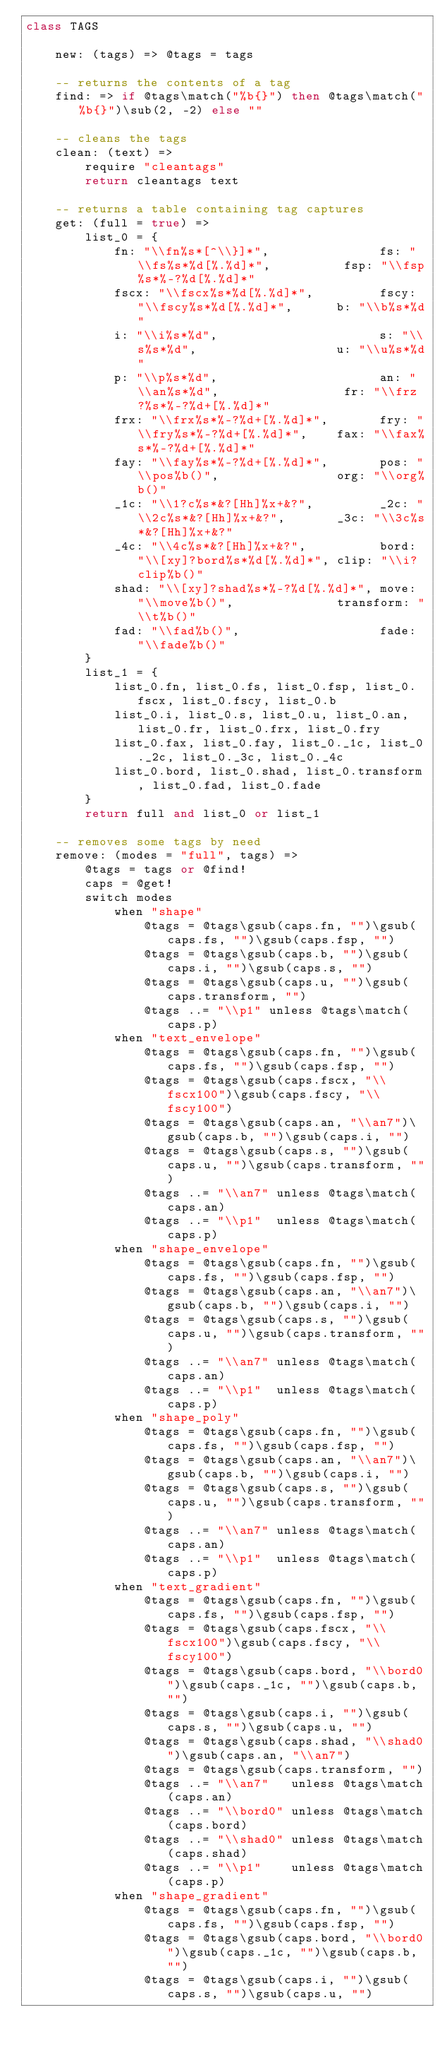<code> <loc_0><loc_0><loc_500><loc_500><_MoonScript_>class TAGS

    new: (tags) => @tags = tags

    -- returns the contents of a tag
    find: => if @tags\match("%b{}") then @tags\match("%b{}")\sub(2, -2) else ""

    -- cleans the tags
    clean: (text) =>
        require "cleantags"
        return cleantags text

    -- returns a table containing tag captures
    get: (full = true) =>
        list_0 = {
            fn: "\\fn%s*[^\\}]*",               fs: "\\fs%s*%d[%.%d]*",          fsp: "\\fsp%s*%-?%d[%.%d]*"
            fscx: "\\fscx%s*%d[%.%d]*",         fscy: "\\fscy%s*%d[%.%d]*",      b: "\\b%s*%d"
            i: "\\i%s*%d",                      s: "\\s%s*%d",                   u: "\\u%s*%d"
            p: "\\p%s*%d",                      an: "\\an%s*%d",                 fr: "\\frz?%s*%-?%d+[%.%d]*"
            frx: "\\frx%s*%-?%d+[%.%d]*",       fry: "\\fry%s*%-?%d+[%.%d]*",    fax: "\\fax%s*%-?%d+[%.%d]*"
            fay: "\\fay%s*%-?%d+[%.%d]*",       pos: "\\pos%b()",                org: "\\org%b()"
            _1c: "\\1?c%s*&?[Hh]%x+&?",         _2c: "\\2c%s*&?[Hh]%x+&?",       _3c: "\\3c%s*&?[Hh]%x+&?"
            _4c: "\\4c%s*&?[Hh]%x+&?",          bord: "\\[xy]?bord%s*%d[%.%d]*", clip: "\\i?clip%b()"
            shad: "\\[xy]?shad%s*%-?%d[%.%d]*", move: "\\move%b()",              transform: "\\t%b()"
            fad: "\\fad%b()",                   fade: "\\fade%b()"
        }
        list_1 = {
            list_0.fn, list_0.fs, list_0.fsp, list_0.fscx, list_0.fscy, list_0.b
            list_0.i, list_0.s, list_0.u, list_0.an, list_0.fr, list_0.frx, list_0.fry
            list_0.fax, list_0.fay, list_0._1c, list_0._2c, list_0._3c, list_0._4c
            list_0.bord, list_0.shad, list_0.transform, list_0.fad, list_0.fade
        }
        return full and list_0 or list_1

    -- removes some tags by need
    remove: (modes = "full", tags) =>
        @tags = tags or @find!
        caps = @get!
        switch modes
            when "shape"
                @tags = @tags\gsub(caps.fn, "")\gsub(caps.fs, "")\gsub(caps.fsp, "")
                @tags = @tags\gsub(caps.b, "")\gsub(caps.i, "")\gsub(caps.s, "")
                @tags = @tags\gsub(caps.u, "")\gsub(caps.transform, "")
                @tags ..= "\\p1" unless @tags\match(caps.p)
            when "text_envelope"
                @tags = @tags\gsub(caps.fn, "")\gsub(caps.fs, "")\gsub(caps.fsp, "")
                @tags = @tags\gsub(caps.fscx, "\\fscx100")\gsub(caps.fscy, "\\fscy100")
                @tags = @tags\gsub(caps.an, "\\an7")\gsub(caps.b, "")\gsub(caps.i, "")
                @tags = @tags\gsub(caps.s, "")\gsub(caps.u, "")\gsub(caps.transform, "")
                @tags ..= "\\an7" unless @tags\match(caps.an)
                @tags ..= "\\p1"  unless @tags\match(caps.p)
            when "shape_envelope"
                @tags = @tags\gsub(caps.fn, "")\gsub(caps.fs, "")\gsub(caps.fsp, "")
                @tags = @tags\gsub(caps.an, "\\an7")\gsub(caps.b, "")\gsub(caps.i, "")
                @tags = @tags\gsub(caps.s, "")\gsub(caps.u, "")\gsub(caps.transform, "")
                @tags ..= "\\an7" unless @tags\match(caps.an)
                @tags ..= "\\p1"  unless @tags\match(caps.p)
            when "shape_poly"
                @tags = @tags\gsub(caps.fn, "")\gsub(caps.fs, "")\gsub(caps.fsp, "")
                @tags = @tags\gsub(caps.an, "\\an7")\gsub(caps.b, "")\gsub(caps.i, "")
                @tags = @tags\gsub(caps.s, "")\gsub(caps.u, "")\gsub(caps.transform, "")
                @tags ..= "\\an7" unless @tags\match(caps.an)
                @tags ..= "\\p1"  unless @tags\match(caps.p)
            when "text_gradient"
                @tags = @tags\gsub(caps.fn, "")\gsub(caps.fs, "")\gsub(caps.fsp, "")
                @tags = @tags\gsub(caps.fscx, "\\fscx100")\gsub(caps.fscy, "\\fscy100")
                @tags = @tags\gsub(caps.bord, "\\bord0")\gsub(caps._1c, "")\gsub(caps.b, "")
                @tags = @tags\gsub(caps.i, "")\gsub(caps.s, "")\gsub(caps.u, "")
                @tags = @tags\gsub(caps.shad, "\\shad0")\gsub(caps.an, "\\an7")
                @tags = @tags\gsub(caps.transform, "")
                @tags ..= "\\an7"   unless @tags\match(caps.an)
                @tags ..= "\\bord0" unless @tags\match(caps.bord)
                @tags ..= "\\shad0" unless @tags\match(caps.shad)
                @tags ..= "\\p1"    unless @tags\match(caps.p)
            when "shape_gradient"
                @tags = @tags\gsub(caps.fn, "")\gsub(caps.fs, "")\gsub(caps.fsp, "")
                @tags = @tags\gsub(caps.bord, "\\bord0")\gsub(caps._1c, "")\gsub(caps.b, "")
                @tags = @tags\gsub(caps.i, "")\gsub(caps.s, "")\gsub(caps.u, "")</code> 